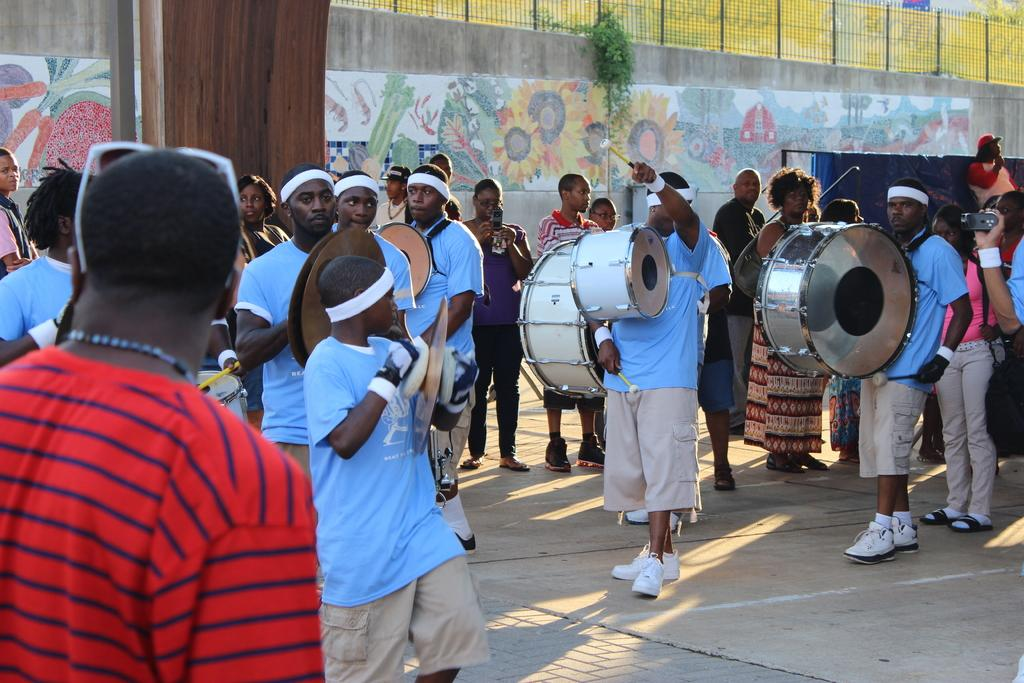What is happening in the image involving a group of people? Some people are playing drums, while others are standing. What type of musical instrument can be seen in the image? Drums are visible in the image. What is present in the background of the image? There is a wall in the background of the image. How is the wall decorated or designed? The wall is painted. What type of snow can be seen falling in the image? There is no snow present in the image; it is a group of people with some playing drums and others standing. 